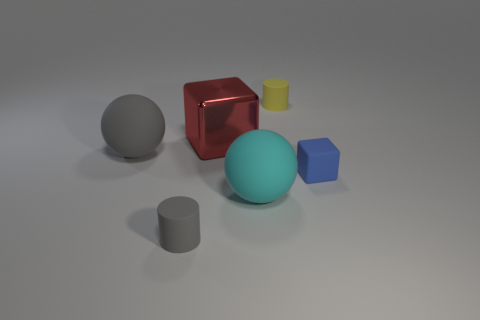How many objects are in the image, and do they follow a pattern? There are six objects in the image: a sphere, a cube, a cylinder, and three objects with hexagonal, pentagonal, and circular bases. They seem to be arranged in no discernible pattern but offer a study in geometric shapes and their attributes. Could you elaborate on the potential purpose of this arrangement? The arrangement could be part of a study or display highlighting geometric shapes and the way light interacts with various surfaces, perhaps in an educational setting or a graphical rendering showcase. 